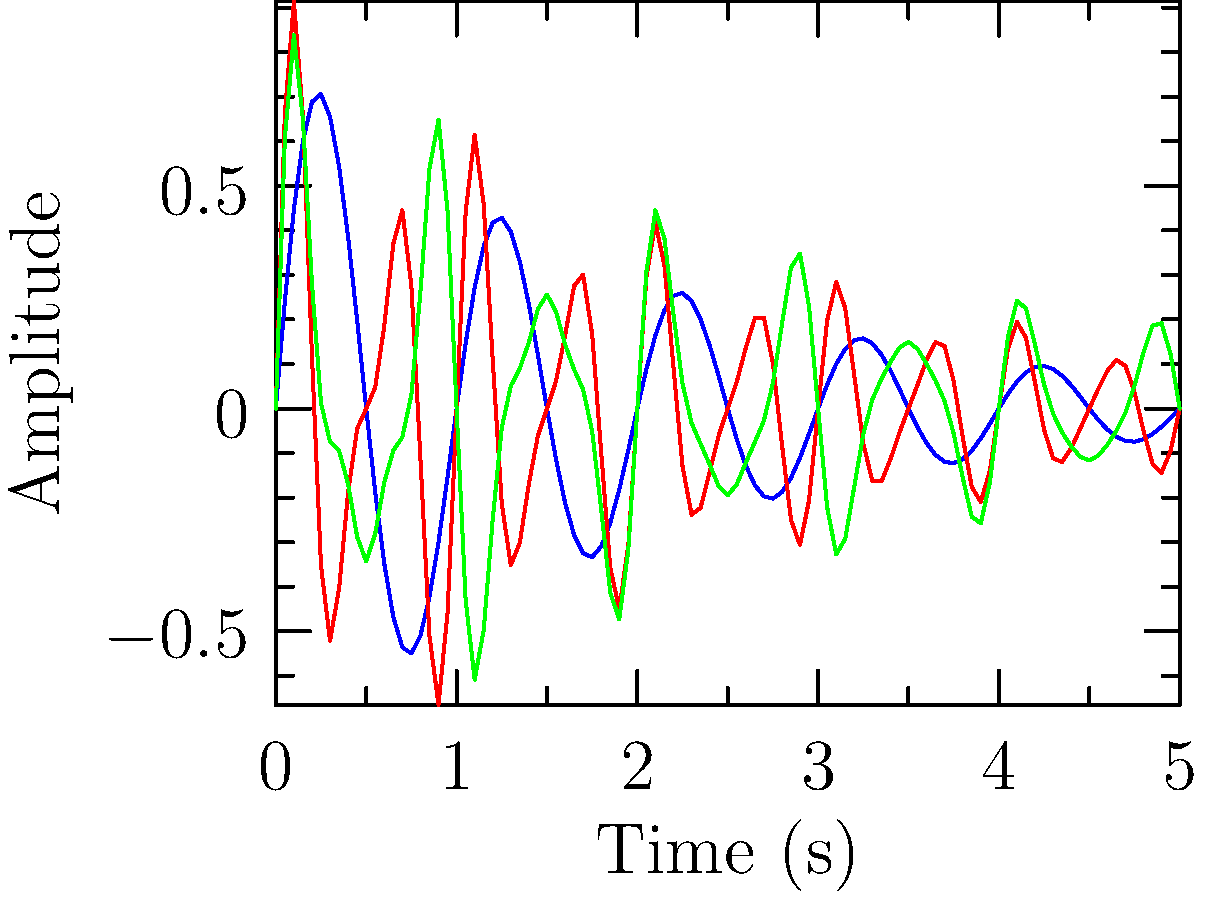Analyze the frequency spectrum graphs of three different synth sounds (A, B, and C) shown above. Which synth sound is likely to have the most complex timbre and why? To determine which synth sound has the most complex timbre, we need to analyze the frequency content and harmonic structure of each graph:

1. Synth A (Blue):
   - Shows a simple sine wave pattern
   - Has a single fundamental frequency
   - Decays smoothly over time

2. Synth B (Red):
   - Displays a more complex waveform
   - Contains at least two distinct frequency components
   - The amplitude envelope shows a slower decay than Synth A

3. Synth C (Green):
   - Exhibits the most complex waveform of the three
   - Contains multiple frequency components (at least three)
   - The amplitude envelope shows the slowest decay

The complexity of a synth's timbre is directly related to the number of harmonics or frequency components present in its sound. More harmonics result in a richer, more complex timbre.

Based on this analysis:
- Synth A has the simplest timbre, with only one apparent frequency component.
- Synth B has a more complex timbre than A, with at least two frequency components.
- Synth C has the most complex timbre, with three or more visible frequency components.

The presence of multiple frequency components in Synth C's waveform indicates a harmonically rich sound with more overtones, resulting in a more complex and interesting timbre.
Answer: Synth C, due to its multiple frequency components and complex waveform. 